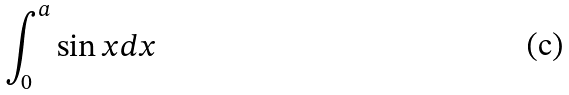Convert formula to latex. <formula><loc_0><loc_0><loc_500><loc_500>\int _ { 0 } ^ { a } \sin x d x</formula> 